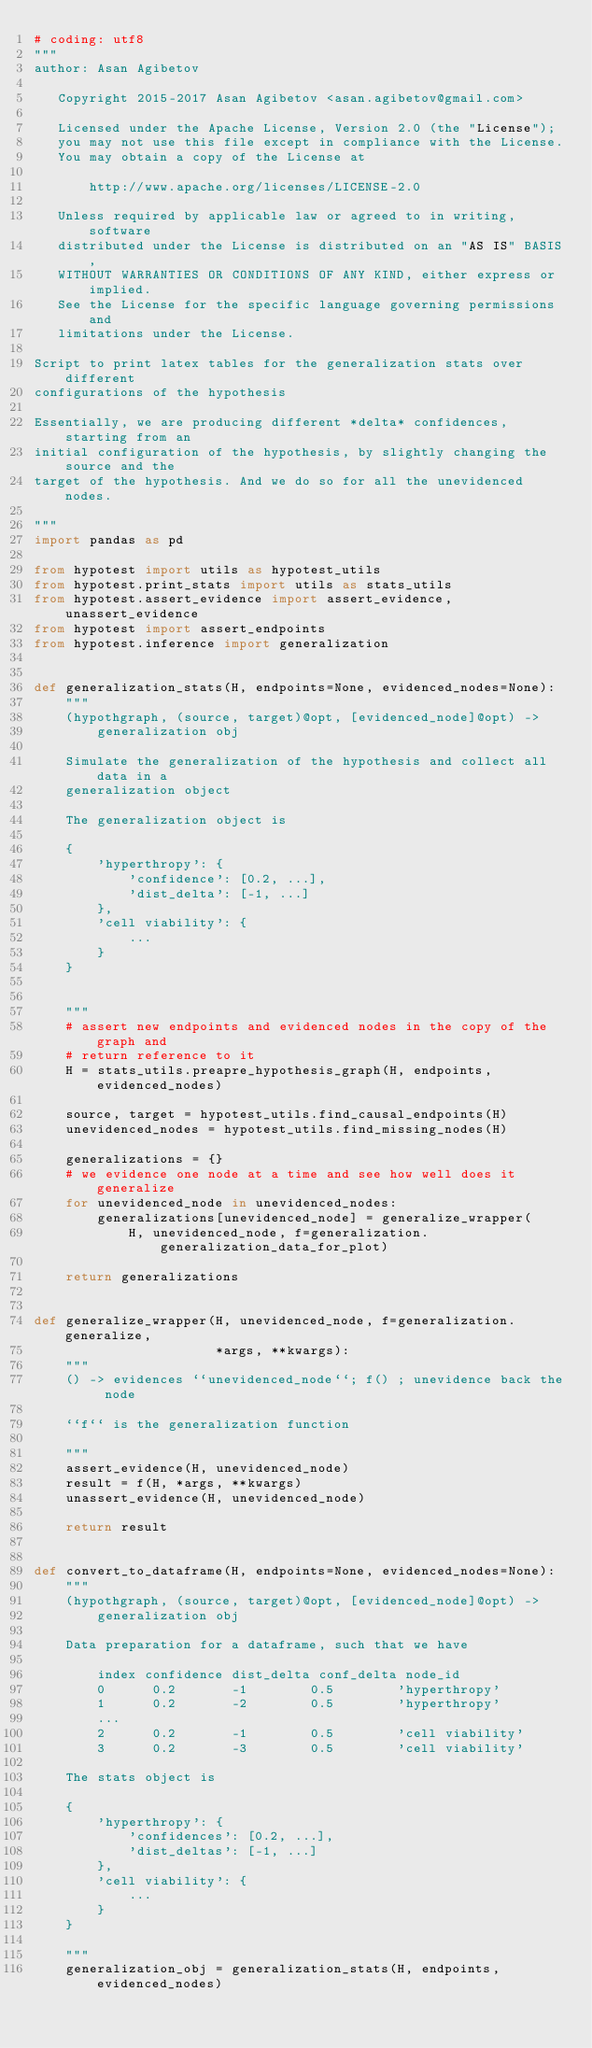<code> <loc_0><loc_0><loc_500><loc_500><_Python_># coding: utf8
"""
author: Asan Agibetov

   Copyright 2015-2017 Asan Agibetov <asan.agibetov@gmail.com>

   Licensed under the Apache License, Version 2.0 (the "License");
   you may not use this file except in compliance with the License.
   You may obtain a copy of the License at

       http://www.apache.org/licenses/LICENSE-2.0

   Unless required by applicable law or agreed to in writing, software
   distributed under the License is distributed on an "AS IS" BASIS,
   WITHOUT WARRANTIES OR CONDITIONS OF ANY KIND, either express or implied.
   See the License for the specific language governing permissions and
   limitations under the License.

Script to print latex tables for the generalization stats over different
configurations of the hypothesis

Essentially, we are producing different *delta* confidences, starting from an
initial configuration of the hypothesis, by slightly changing the source and the
target of the hypothesis. And we do so for all the unevidenced nodes.

"""
import pandas as pd

from hypotest import utils as hypotest_utils
from hypotest.print_stats import utils as stats_utils
from hypotest.assert_evidence import assert_evidence, unassert_evidence
from hypotest import assert_endpoints
from hypotest.inference import generalization


def generalization_stats(H, endpoints=None, evidenced_nodes=None):
    """
    (hypothgraph, (source, target)@opt, [evidenced_node]@opt) ->
        generalization obj

    Simulate the generalization of the hypothesis and collect all data in a
    generalization object

    The generalization object is

    {
        'hyperthropy': {
            'confidence': [0.2, ...],
            'dist_delta': [-1, ...]
        },
        'cell viability': {
            ...
        }
    }


    """
    # assert new endpoints and evidenced nodes in the copy of the graph and
    # return reference to it
    H = stats_utils.preapre_hypothesis_graph(H, endpoints, evidenced_nodes)

    source, target = hypotest_utils.find_causal_endpoints(H)
    unevidenced_nodes = hypotest_utils.find_missing_nodes(H)

    generalizations = {}
    # we evidence one node at a time and see how well does it generalize
    for unevidenced_node in unevidenced_nodes:
        generalizations[unevidenced_node] = generalize_wrapper(
            H, unevidenced_node, f=generalization.generalization_data_for_plot)

    return generalizations


def generalize_wrapper(H, unevidenced_node, f=generalization.generalize,
                       *args, **kwargs):
    """
    () -> evidences ``unevidenced_node``; f() ; unevidence back the node

    ``f`` is the generalization function

    """
    assert_evidence(H, unevidenced_node)
    result = f(H, *args, **kwargs)
    unassert_evidence(H, unevidenced_node)

    return result


def convert_to_dataframe(H, endpoints=None, evidenced_nodes=None):
    """
    (hypothgraph, (source, target)@opt, [evidenced_node]@opt) ->
        generalization obj

    Data preparation for a dataframe, such that we have

        index confidence dist_delta conf_delta node_id
        0      0.2       -1        0.5        'hyperthropy'
        1      0.2       -2        0.5        'hyperthropy'
        ...
        2      0.2       -1        0.5        'cell viability'
        3      0.2       -3        0.5        'cell viability'

    The stats object is

    {
        'hyperthropy': {
            'confidences': [0.2, ...],
            'dist_deltas': [-1, ...]
        },
        'cell viability': {
            ...
        }
    }

    """
    generalization_obj = generalization_stats(H, endpoints, evidenced_nodes)</code> 